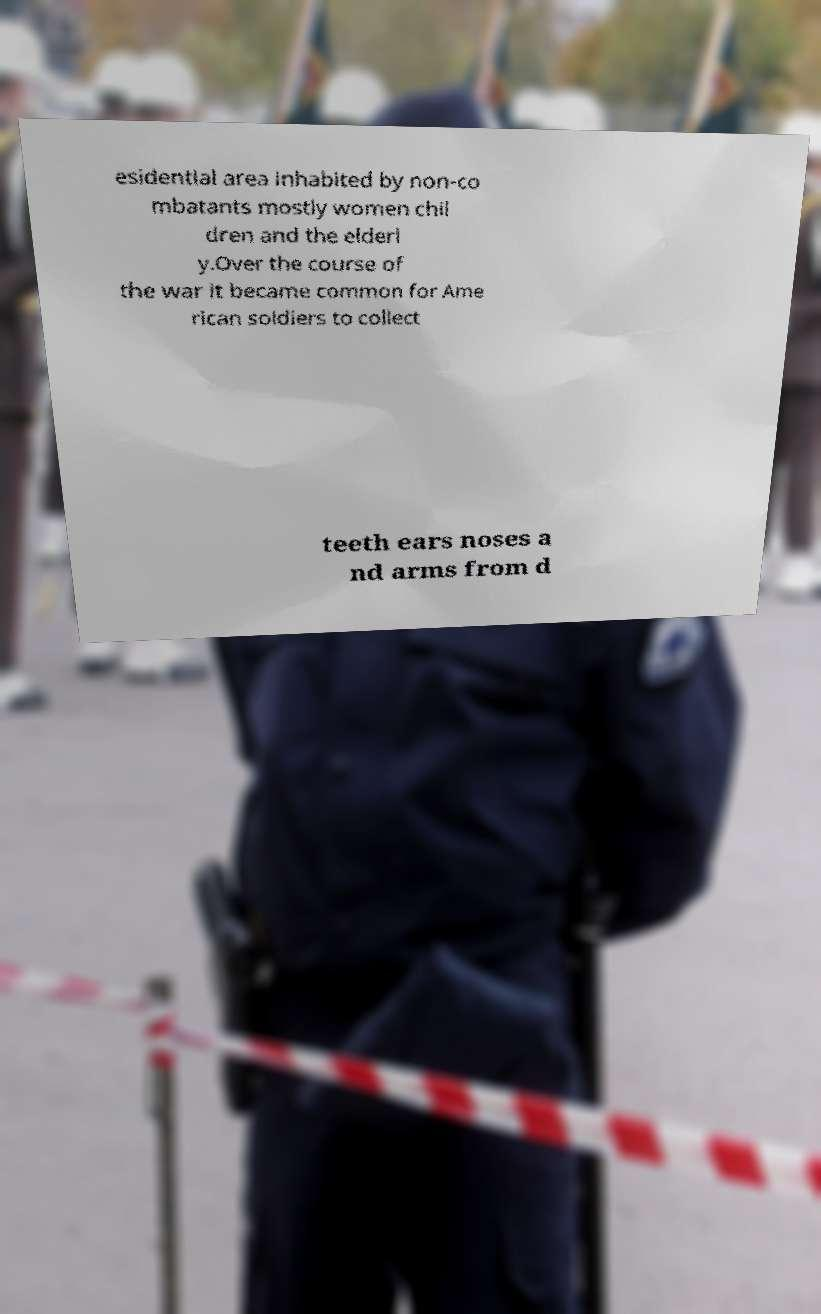Can you read and provide the text displayed in the image?This photo seems to have some interesting text. Can you extract and type it out for me? esidential area inhabited by non-co mbatants mostly women chil dren and the elderl y.Over the course of the war it became common for Ame rican soldiers to collect teeth ears noses a nd arms from d 